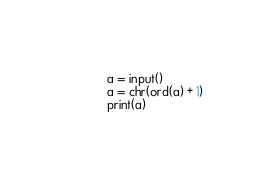Convert code to text. <code><loc_0><loc_0><loc_500><loc_500><_Python_>a = input()
a = chr(ord(a) + 1)
print(a)
</code> 